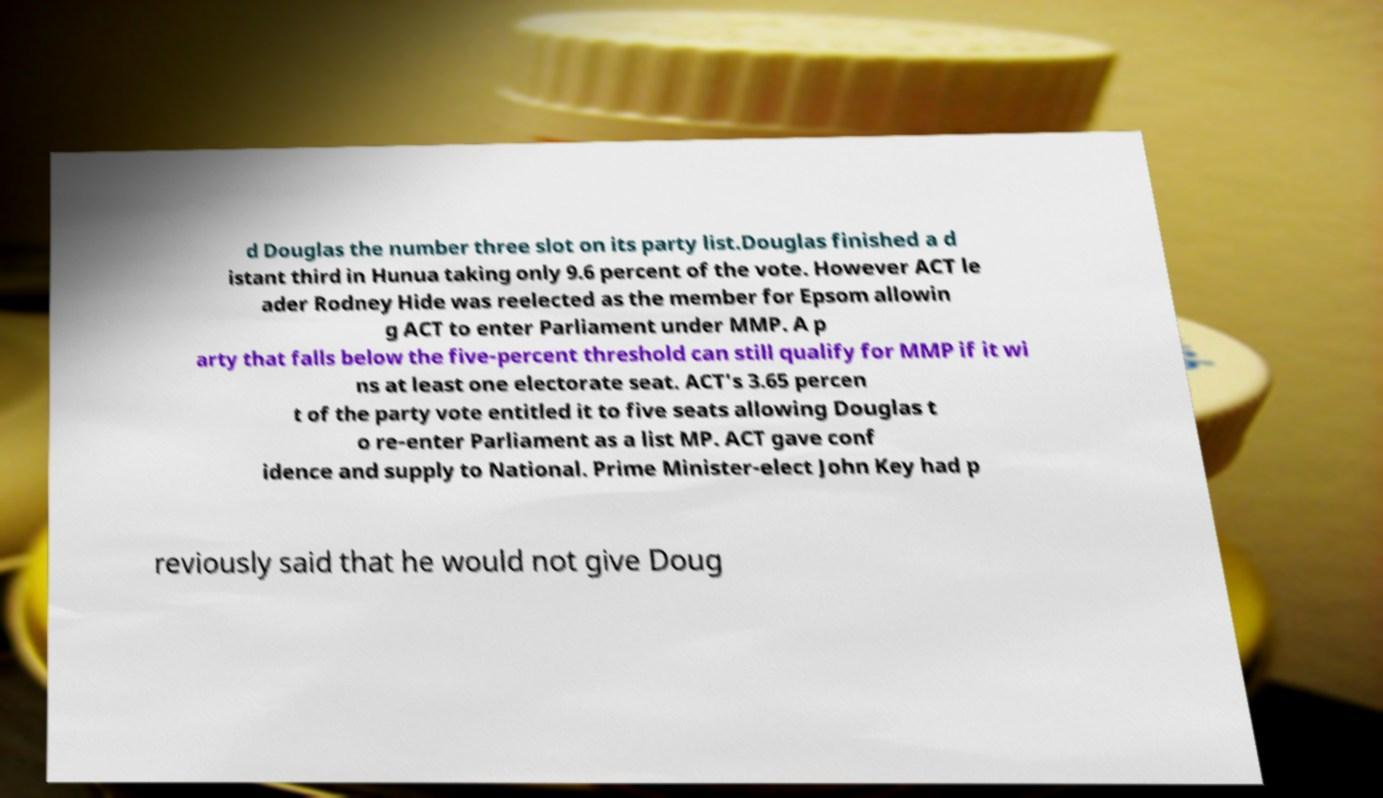I need the written content from this picture converted into text. Can you do that? d Douglas the number three slot on its party list.Douglas finished a d istant third in Hunua taking only 9.6 percent of the vote. However ACT le ader Rodney Hide was reelected as the member for Epsom allowin g ACT to enter Parliament under MMP. A p arty that falls below the five-percent threshold can still qualify for MMP if it wi ns at least one electorate seat. ACT's 3.65 percen t of the party vote entitled it to five seats allowing Douglas t o re-enter Parliament as a list MP. ACT gave conf idence and supply to National. Prime Minister-elect John Key had p reviously said that he would not give Doug 